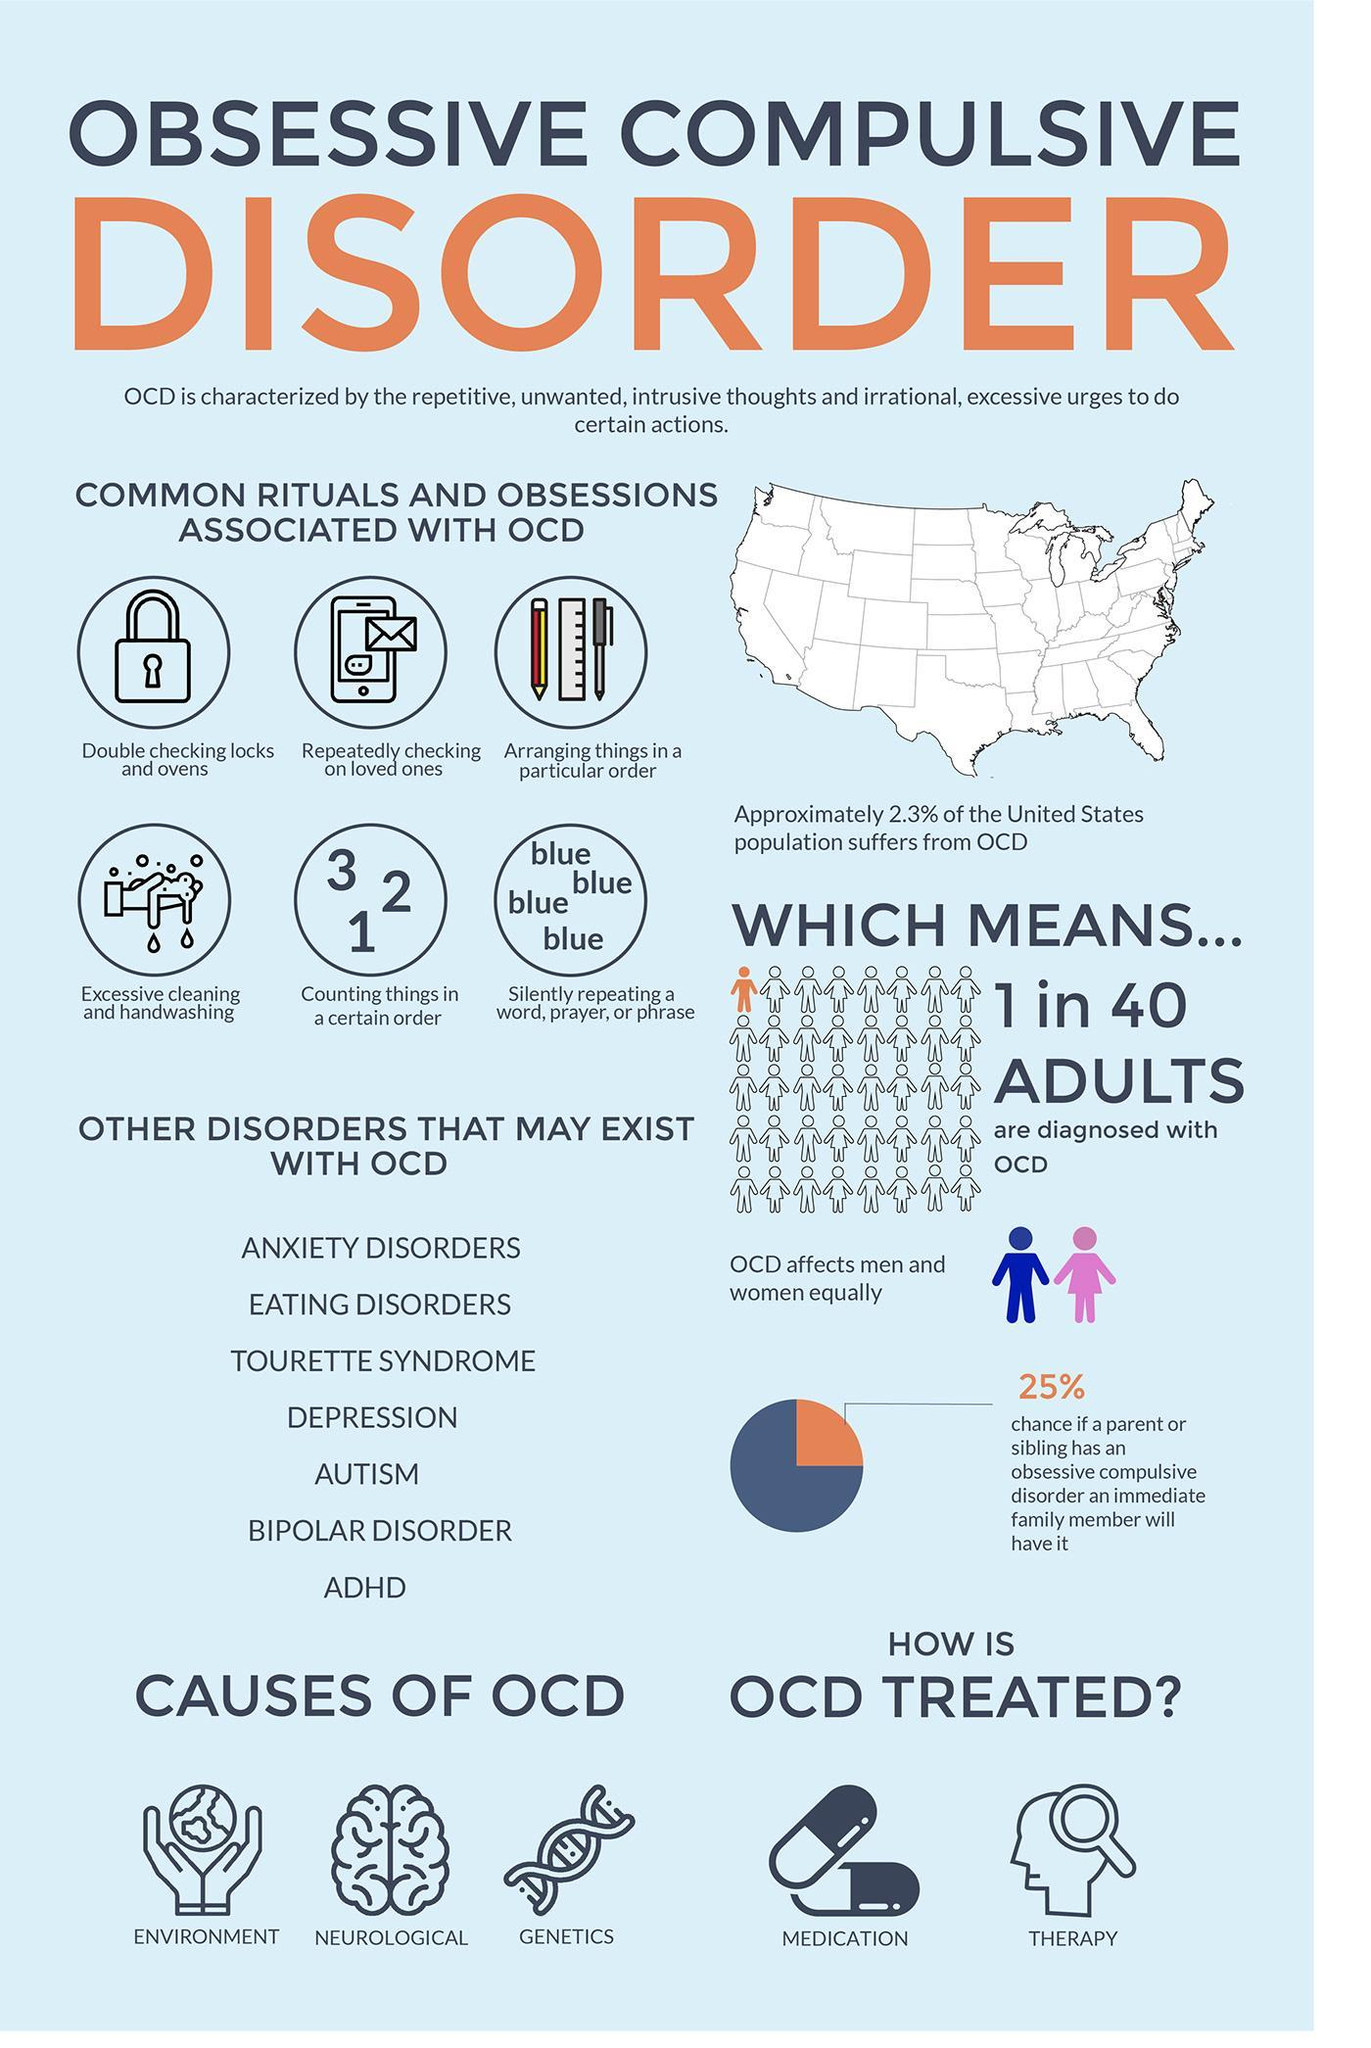What are three fundamental causes of OCD?
Answer the question with a short phrase. ENVIRONMENT, NEUROLOGICAL, GENETICS What are the treatments used for OCD? Medication, Therapy 